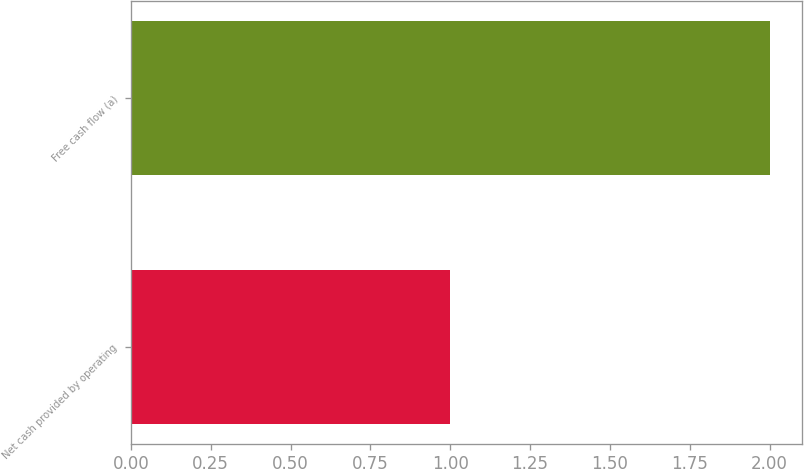Convert chart to OTSL. <chart><loc_0><loc_0><loc_500><loc_500><bar_chart><fcel>Net cash provided by operating<fcel>Free cash flow (a)<nl><fcel>1<fcel>2<nl></chart> 